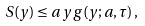Convert formula to latex. <formula><loc_0><loc_0><loc_500><loc_500>S ( y ) \leq a \, y \, g ( y ; a , \tau ) \, ,</formula> 